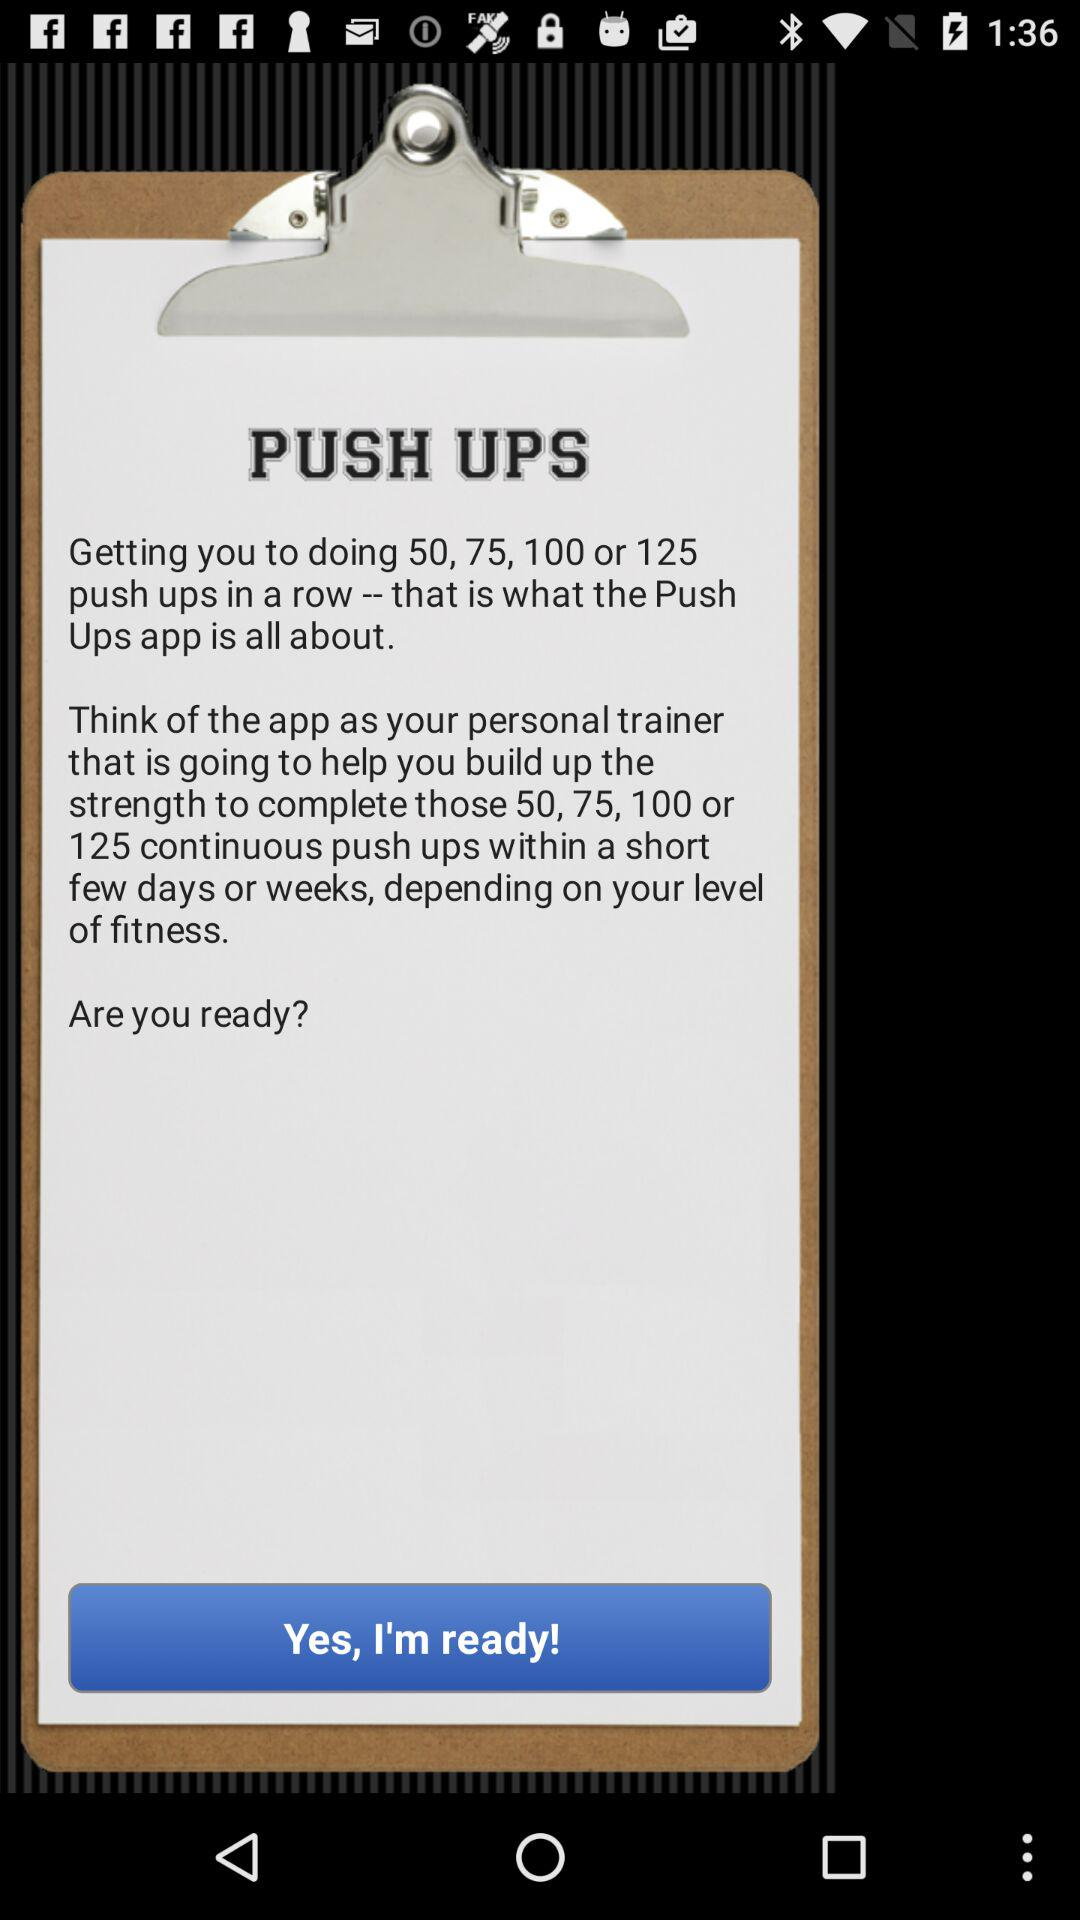How many push ups are mentioned in the text?
Answer the question using a single word or phrase. 50, 75, 100, 125 